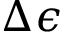<formula> <loc_0><loc_0><loc_500><loc_500>\Delta \epsilon</formula> 